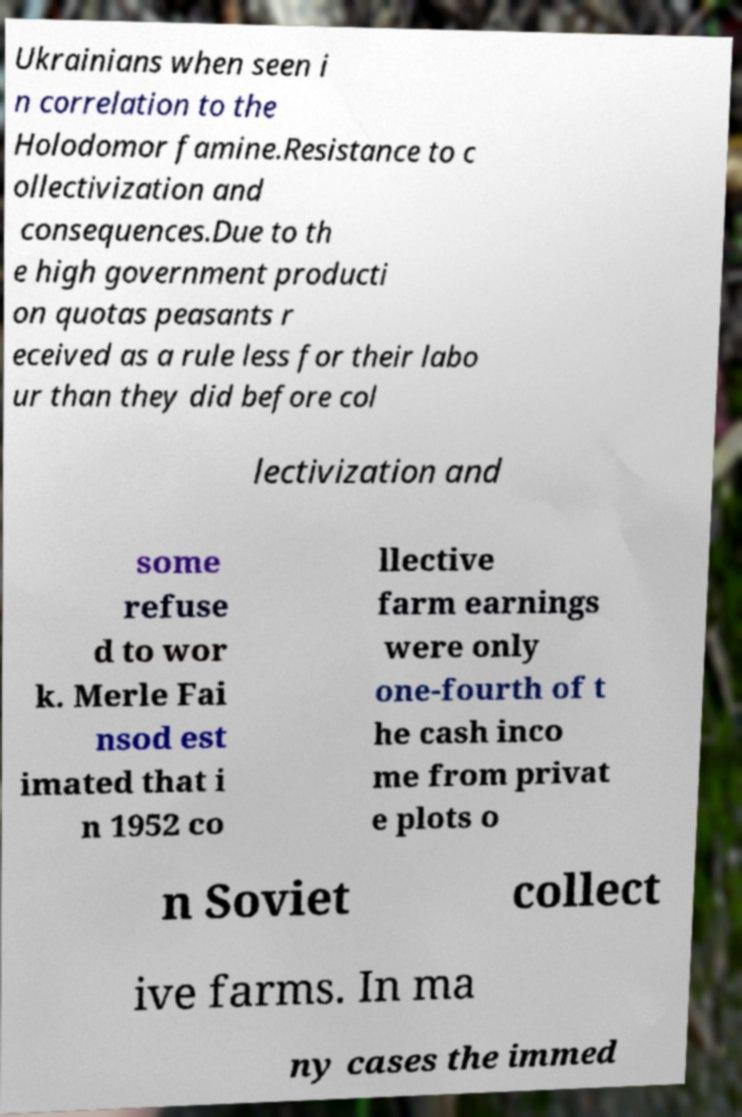Could you extract and type out the text from this image? Ukrainians when seen i n correlation to the Holodomor famine.Resistance to c ollectivization and consequences.Due to th e high government producti on quotas peasants r eceived as a rule less for their labo ur than they did before col lectivization and some refuse d to wor k. Merle Fai nsod est imated that i n 1952 co llective farm earnings were only one-fourth of t he cash inco me from privat e plots o n Soviet collect ive farms. In ma ny cases the immed 